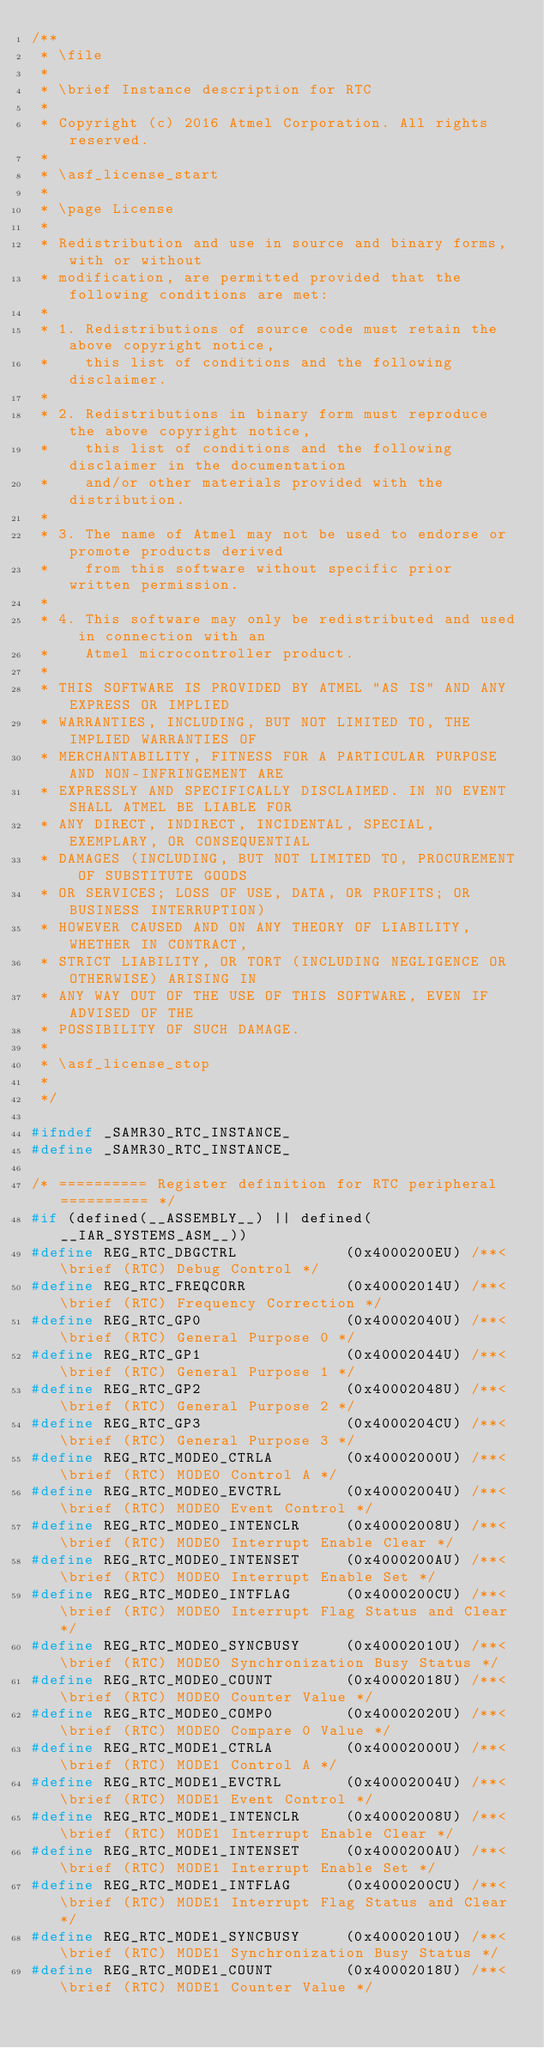Convert code to text. <code><loc_0><loc_0><loc_500><loc_500><_C_>/**
 * \file
 *
 * \brief Instance description for RTC
 *
 * Copyright (c) 2016 Atmel Corporation. All rights reserved.
 *
 * \asf_license_start
 *
 * \page License
 *
 * Redistribution and use in source and binary forms, with or without
 * modification, are permitted provided that the following conditions are met:
 *
 * 1. Redistributions of source code must retain the above copyright notice,
 *    this list of conditions and the following disclaimer.
 *
 * 2. Redistributions in binary form must reproduce the above copyright notice,
 *    this list of conditions and the following disclaimer in the documentation
 *    and/or other materials provided with the distribution.
 *
 * 3. The name of Atmel may not be used to endorse or promote products derived
 *    from this software without specific prior written permission.
 *
 * 4. This software may only be redistributed and used in connection with an
 *    Atmel microcontroller product.
 *
 * THIS SOFTWARE IS PROVIDED BY ATMEL "AS IS" AND ANY EXPRESS OR IMPLIED
 * WARRANTIES, INCLUDING, BUT NOT LIMITED TO, THE IMPLIED WARRANTIES OF
 * MERCHANTABILITY, FITNESS FOR A PARTICULAR PURPOSE AND NON-INFRINGEMENT ARE
 * EXPRESSLY AND SPECIFICALLY DISCLAIMED. IN NO EVENT SHALL ATMEL BE LIABLE FOR
 * ANY DIRECT, INDIRECT, INCIDENTAL, SPECIAL, EXEMPLARY, OR CONSEQUENTIAL
 * DAMAGES (INCLUDING, BUT NOT LIMITED TO, PROCUREMENT OF SUBSTITUTE GOODS
 * OR SERVICES; LOSS OF USE, DATA, OR PROFITS; OR BUSINESS INTERRUPTION)
 * HOWEVER CAUSED AND ON ANY THEORY OF LIABILITY, WHETHER IN CONTRACT,
 * STRICT LIABILITY, OR TORT (INCLUDING NEGLIGENCE OR OTHERWISE) ARISING IN
 * ANY WAY OUT OF THE USE OF THIS SOFTWARE, EVEN IF ADVISED OF THE
 * POSSIBILITY OF SUCH DAMAGE.
 *
 * \asf_license_stop
 *
 */

#ifndef _SAMR30_RTC_INSTANCE_
#define _SAMR30_RTC_INSTANCE_

/* ========== Register definition for RTC peripheral ========== */
#if (defined(__ASSEMBLY__) || defined(__IAR_SYSTEMS_ASM__))
#define REG_RTC_DBGCTRL            (0x4000200EU) /**< \brief (RTC) Debug Control */
#define REG_RTC_FREQCORR           (0x40002014U) /**< \brief (RTC) Frequency Correction */
#define REG_RTC_GP0                (0x40002040U) /**< \brief (RTC) General Purpose 0 */
#define REG_RTC_GP1                (0x40002044U) /**< \brief (RTC) General Purpose 1 */
#define REG_RTC_GP2                (0x40002048U) /**< \brief (RTC) General Purpose 2 */
#define REG_RTC_GP3                (0x4000204CU) /**< \brief (RTC) General Purpose 3 */
#define REG_RTC_MODE0_CTRLA        (0x40002000U) /**< \brief (RTC) MODE0 Control A */
#define REG_RTC_MODE0_EVCTRL       (0x40002004U) /**< \brief (RTC) MODE0 Event Control */
#define REG_RTC_MODE0_INTENCLR     (0x40002008U) /**< \brief (RTC) MODE0 Interrupt Enable Clear */
#define REG_RTC_MODE0_INTENSET     (0x4000200AU) /**< \brief (RTC) MODE0 Interrupt Enable Set */
#define REG_RTC_MODE0_INTFLAG      (0x4000200CU) /**< \brief (RTC) MODE0 Interrupt Flag Status and Clear */
#define REG_RTC_MODE0_SYNCBUSY     (0x40002010U) /**< \brief (RTC) MODE0 Synchronization Busy Status */
#define REG_RTC_MODE0_COUNT        (0x40002018U) /**< \brief (RTC) MODE0 Counter Value */
#define REG_RTC_MODE0_COMP0        (0x40002020U) /**< \brief (RTC) MODE0 Compare 0 Value */
#define REG_RTC_MODE1_CTRLA        (0x40002000U) /**< \brief (RTC) MODE1 Control A */
#define REG_RTC_MODE1_EVCTRL       (0x40002004U) /**< \brief (RTC) MODE1 Event Control */
#define REG_RTC_MODE1_INTENCLR     (0x40002008U) /**< \brief (RTC) MODE1 Interrupt Enable Clear */
#define REG_RTC_MODE1_INTENSET     (0x4000200AU) /**< \brief (RTC) MODE1 Interrupt Enable Set */
#define REG_RTC_MODE1_INTFLAG      (0x4000200CU) /**< \brief (RTC) MODE1 Interrupt Flag Status and Clear */
#define REG_RTC_MODE1_SYNCBUSY     (0x40002010U) /**< \brief (RTC) MODE1 Synchronization Busy Status */
#define REG_RTC_MODE1_COUNT        (0x40002018U) /**< \brief (RTC) MODE1 Counter Value */</code> 